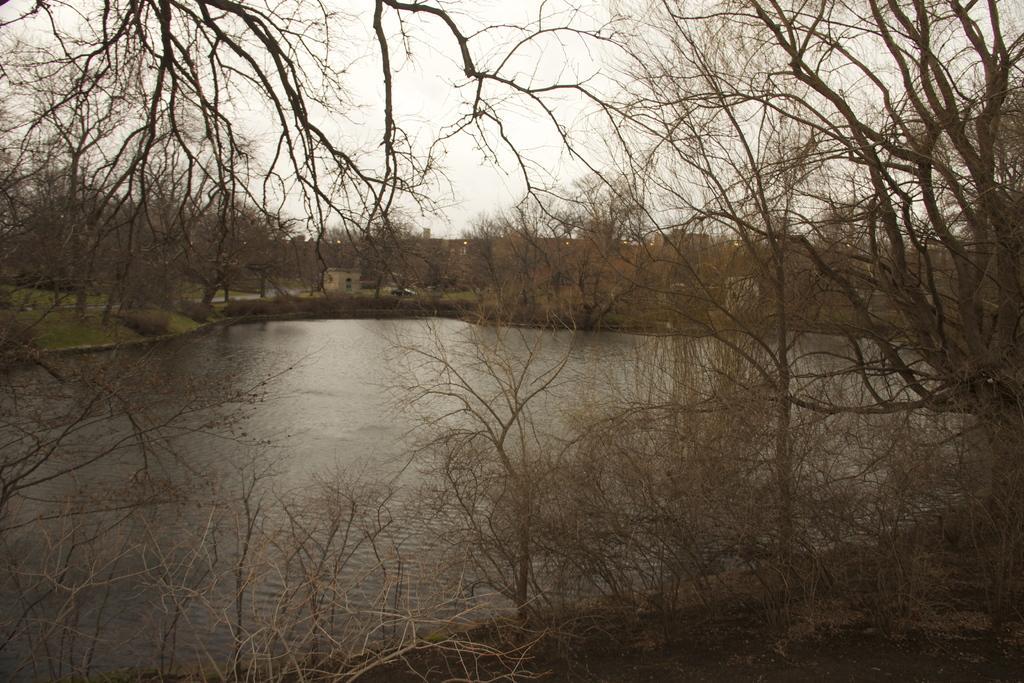Describe this image in one or two sentences. At the center of the image there is a lake, around that there are trees. In the background there is a building and the sky. 